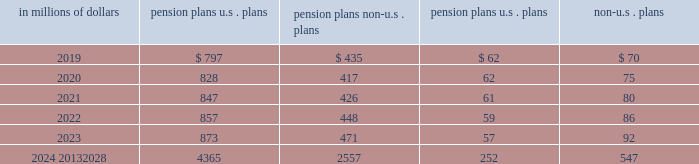Investment strategy the company 2019s global pension and postretirement funds 2019 investment strategy is to invest in a prudent manner for the exclusive purpose of providing benefits to participants .
The investment strategies are targeted to produce a total return that , when combined with the company 2019s contributions to the funds , will maintain the funds 2019 ability to meet all required benefit obligations .
Risk is controlled through diversification of asset types and investments in domestic and international equities , fixed income securities and cash and short-term investments .
The target asset allocation in most locations outside the u.s .
Is primarily in equity and debt securities .
These allocations may vary by geographic region and country depending on the nature of applicable obligations and various other regional considerations .
The wide variation in the actual range of plan asset allocations for the funded non-u.s .
Plans is a result of differing local statutory requirements and economic conditions .
For example , in certain countries local law requires that all pension plan assets must be invested in fixed income investments , government funds or local-country securities .
Significant concentrations of risk in plan assets the assets of the company 2019s pension plans are diversified to limit the impact of any individual investment .
The u.s .
Qualified pension plan is diversified across multiple asset classes , with publicly traded fixed income , hedge funds , publicly traded equity and real estate representing the most significant asset allocations .
Investments in these four asset classes are further diversified across funds , managers , strategies , vintages , sectors and geographies , depending on the specific characteristics of each asset class .
The pension assets for the company 2019s non-u.s .
Significant plans are primarily invested in publicly traded fixed income and publicly traded equity securities .
Oversight and risk management practices the framework for the company 2019s pension oversight process includes monitoring of retirement plans by plan fiduciaries and/or management at the global , regional or country level , as appropriate .
Independent risk management contributes to the risk oversight and monitoring for the company 2019s u.s .
Qualified pension plan and non-u.s .
Significant pension plans .
Although the specific components of the oversight process are tailored to the requirements of each region , country and plan , the following elements are common to the company 2019s monitoring and risk management process : 2022 periodic asset/liability management studies and strategic asset allocation reviews ; 2022 periodic monitoring of funding levels and funding ratios ; 2022 periodic monitoring of compliance with asset allocation guidelines ; 2022 periodic monitoring of asset class and/or investment manager performance against benchmarks ; and 2022 periodic risk capital analysis and stress testing .
Estimated future benefit payments the company expects to pay the following estimated benefit payments in future years: .

What are total estimated future benefit payments in millions for 2020? 
Computations: table_sum(2020, none)
Answer: 1382.0. 